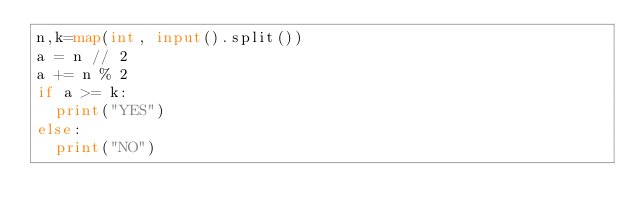Convert code to text. <code><loc_0><loc_0><loc_500><loc_500><_Python_>n,k=map(int, input().split())
a = n // 2
a += n % 2
if a >= k:
  print("YES")
else:
  print("NO")</code> 